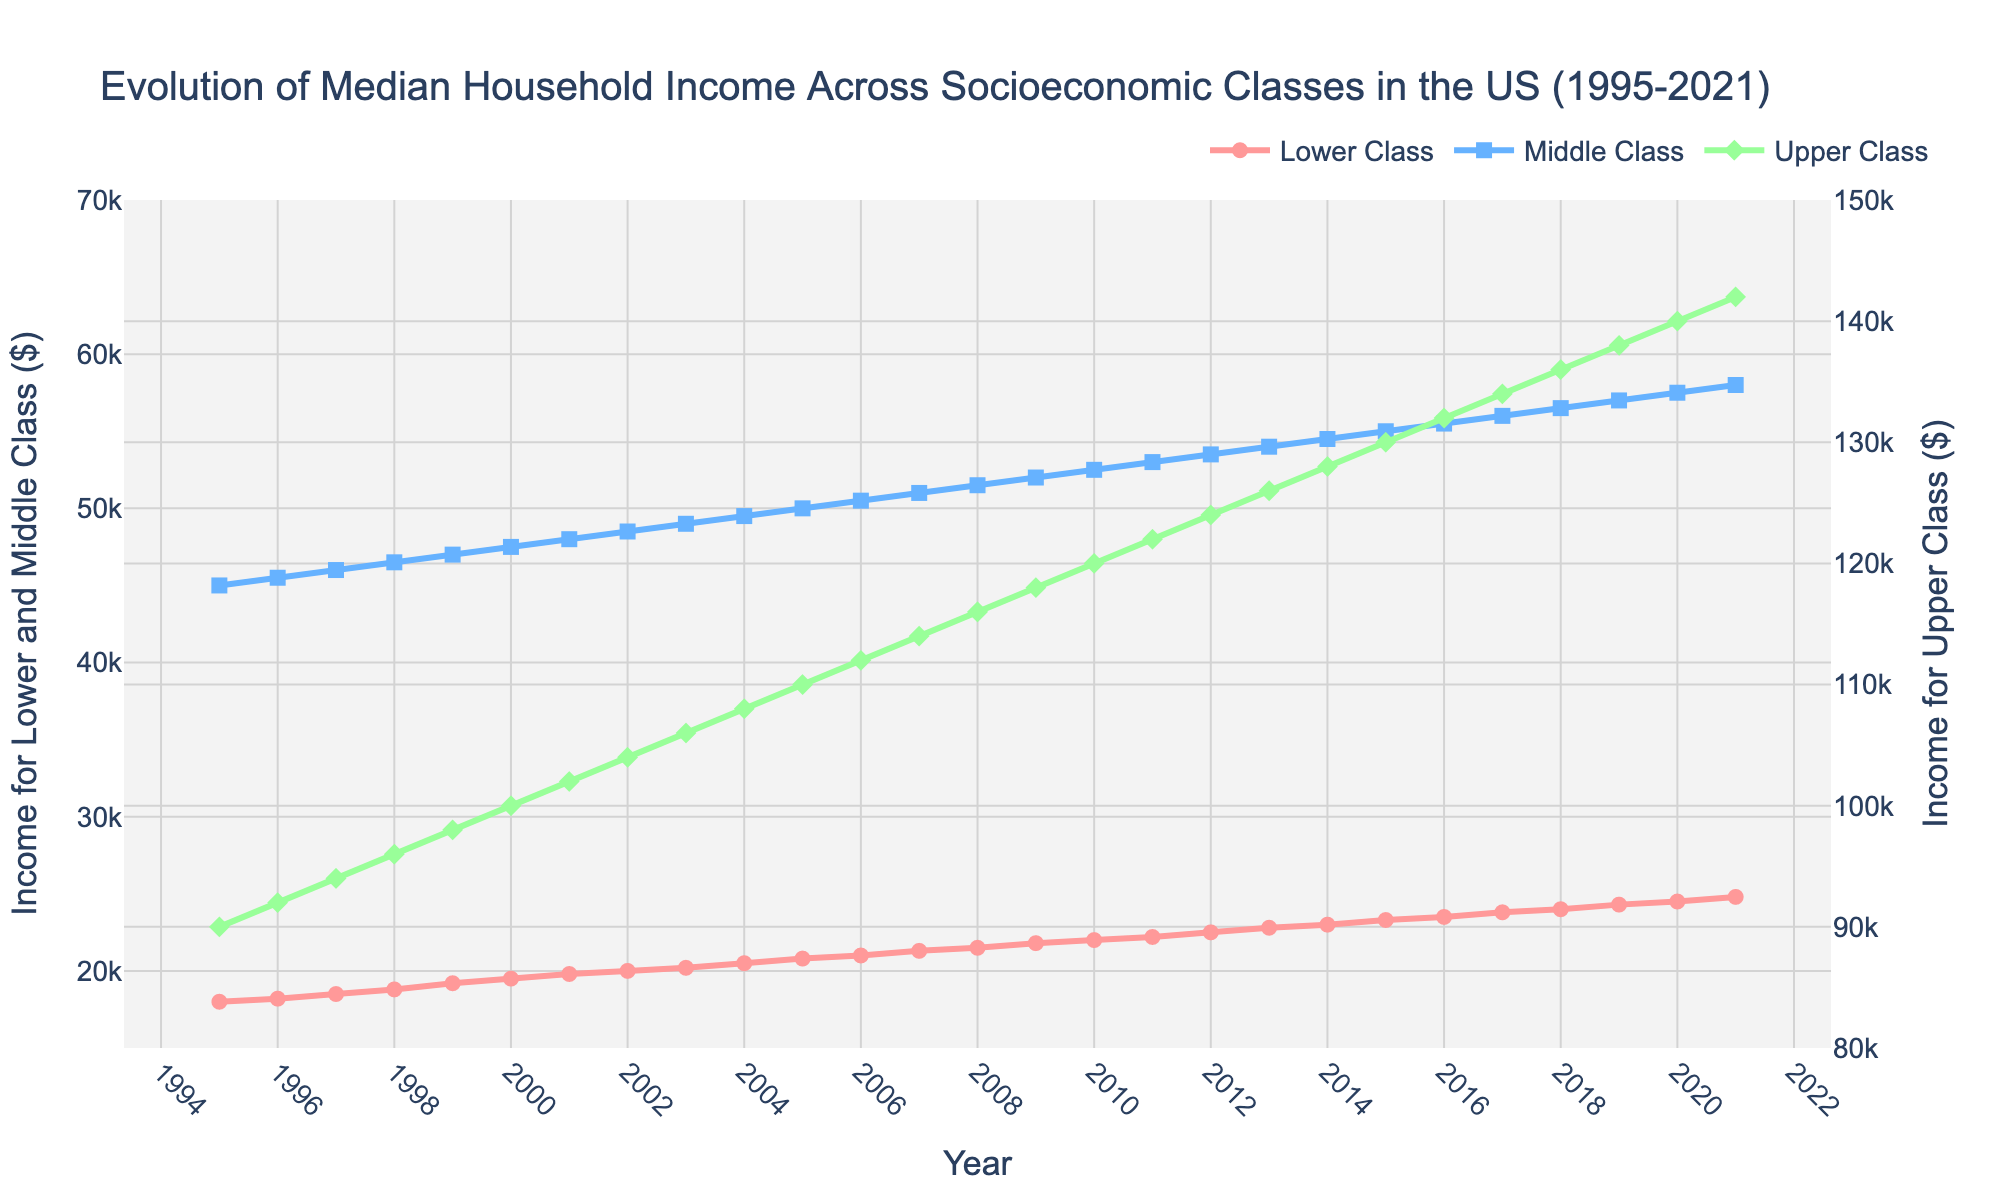What's the title of the figure? The title is usually found at the top of the figure. In this case, it states "Evolution of Median Household Income Across Socioeconomic Classes in the US (1995-2021)."
Answer: Evolution of Median Household Income Across Socioeconomic Classes in the US (1995-2021) What's the color of the line representing the Lower Class? The color can be observed by looking at the legend or the line itself. The Lower Class line is reddish-pink.
Answer: Reddish-pink How many data points are there for the Upper Class income over the years? The data spans from 1995 to 2021, inclusive. Counting these years gives the number of data points: 2021 - 1995 + 1.
Answer: 27 During which year did the Middle Class income reach $50,000? Look for the point on the Middle Class line (blue) where the y-value reaches $50,000. The data shows it is at the year 2005.
Answer: 2005 Which socioeconomic class has the highest median household income in the latest year? Refer to the plot for the year 2021 and compare the values. The Upper Class has the highest value, which is $142,000.
Answer: Upper Class What is the income difference between the Upper Class and Lower Class in the year 2010? Find the values for both classes in 2010: Upper Class ($120,000) and Lower Class ($22,000). The difference is $120,000 - $22,000.
Answer: $98,000 By how much did the median household income for the Lower Class increase from 1995 to 2021? Locate the values for the Lower Class in 1995 ($18,000) and in 2021 ($24,800). The increase is $24,800 - $18,000.
Answer: $6,800 What is the average income for the Middle Class over the entire period? Sum all the Middle Class incomes from 1995 to 2021 and divide by the number of years (27). The total is 1,440,000. Dividing this by 27 gives the average.
Answer: $53,333 Did any socioeconomic class experience a decrease in income between any consecutive years? Examine the figures for each class year by year. No class shows a decrease; they all exhibit continuous increase.
Answer: No What trend can you observe in the median household income for all socioeconomic classes over time? By visual inspection, all three classes show an upward trend in income from 1995 to 2021.
Answer: Upward trend 